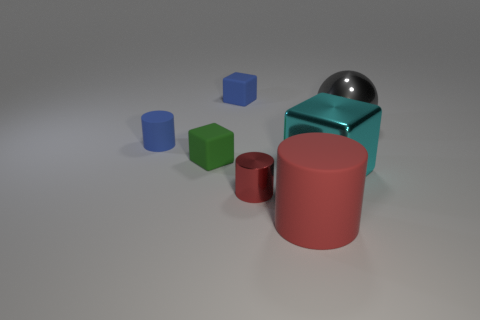Subtract all cyan blocks. How many red cylinders are left? 2 Add 2 blue cylinders. How many objects exist? 9 Subtract all rubber cylinders. How many cylinders are left? 1 Subtract all cylinders. How many objects are left? 4 Subtract all blue cylinders. How many cylinders are left? 2 Add 3 tiny shiny objects. How many tiny shiny objects exist? 4 Subtract 0 yellow blocks. How many objects are left? 7 Subtract 1 blocks. How many blocks are left? 2 Subtract all green blocks. Subtract all yellow cylinders. How many blocks are left? 2 Subtract all purple metallic blocks. Subtract all metal blocks. How many objects are left? 6 